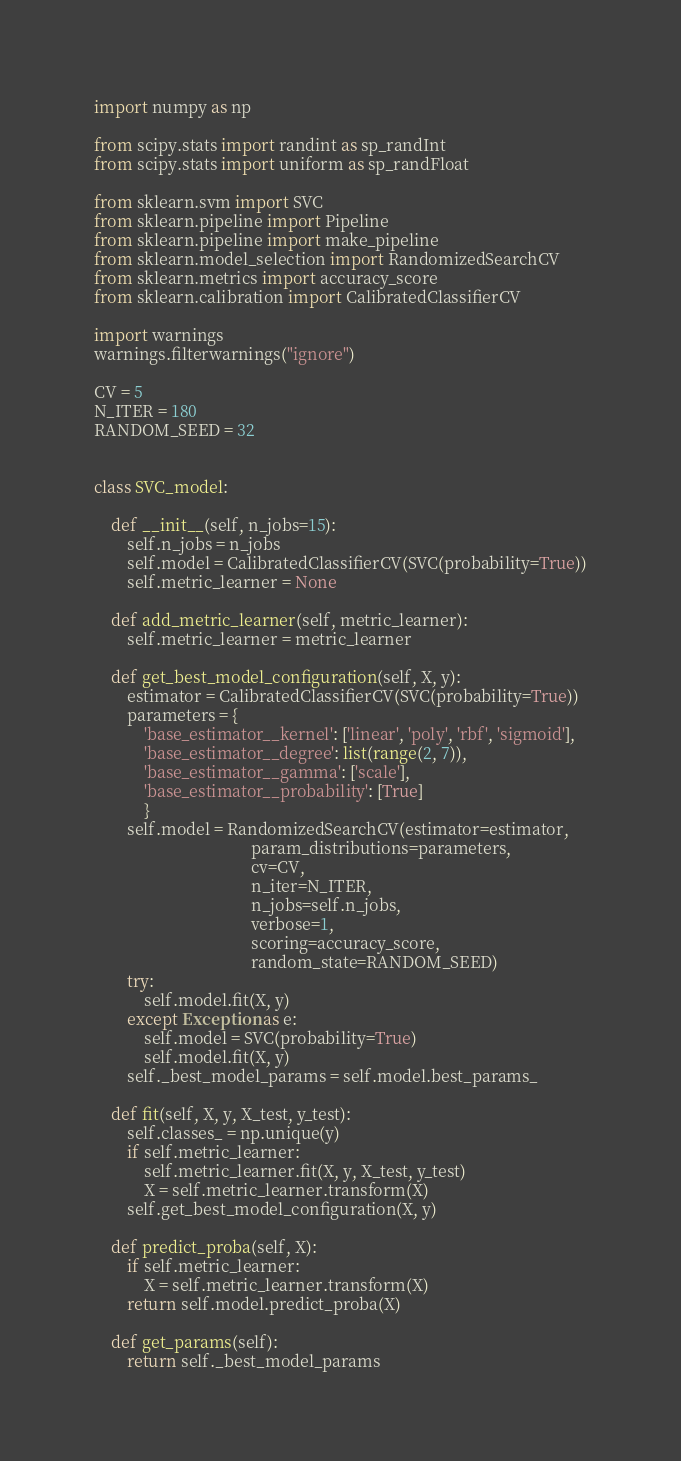Convert code to text. <code><loc_0><loc_0><loc_500><loc_500><_Python_>import numpy as np

from scipy.stats import randint as sp_randInt
from scipy.stats import uniform as sp_randFloat

from sklearn.svm import SVC
from sklearn.pipeline import Pipeline
from sklearn.pipeline import make_pipeline
from sklearn.model_selection import RandomizedSearchCV
from sklearn.metrics import accuracy_score
from sklearn.calibration import CalibratedClassifierCV

import warnings
warnings.filterwarnings("ignore")

CV = 5
N_ITER = 180
RANDOM_SEED = 32


class SVC_model:

    def __init__(self, n_jobs=15):
        self.n_jobs = n_jobs
        self.model = CalibratedClassifierCV(SVC(probability=True))
        self.metric_learner = None

    def add_metric_learner(self, metric_learner):
        self.metric_learner = metric_learner

    def get_best_model_configuration(self, X, y):
        estimator = CalibratedClassifierCV(SVC(probability=True))
        parameters = {
            'base_estimator__kernel': ['linear', 'poly', 'rbf', 'sigmoid'],
            'base_estimator__degree': list(range(2, 7)),
            'base_estimator__gamma': ['scale'],
            'base_estimator__probability': [True]
            }
        self.model = RandomizedSearchCV(estimator=estimator,
                                      param_distributions=parameters,
                                      cv=CV,
                                      n_iter=N_ITER,
                                      n_jobs=self.n_jobs,
                                      verbose=1,
                                      scoring=accuracy_score,
                                      random_state=RANDOM_SEED)
        try:
            self.model.fit(X, y)
        except Exception as e:
            self.model = SVC(probability=True)
            self.model.fit(X, y)
        self._best_model_params = self.model.best_params_

    def fit(self, X, y, X_test, y_test):
        self.classes_ = np.unique(y)
        if self.metric_learner:
            self.metric_learner.fit(X, y, X_test, y_test)
            X = self.metric_learner.transform(X)
        self.get_best_model_configuration(X, y)

    def predict_proba(self, X):
        if self.metric_learner:
            X = self.metric_learner.transform(X)
        return self.model.predict_proba(X)

    def get_params(self):
        return self._best_model_params
</code> 